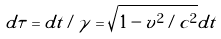Convert formula to latex. <formula><loc_0><loc_0><loc_500><loc_500>d \tau = d t / \gamma = \sqrt { 1 - v ^ { 2 } / c ^ { 2 } } d t</formula> 